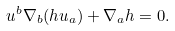<formula> <loc_0><loc_0><loc_500><loc_500>u ^ { b } \nabla _ { b } ( h u _ { a } ) + \nabla _ { a } h = 0 .</formula> 